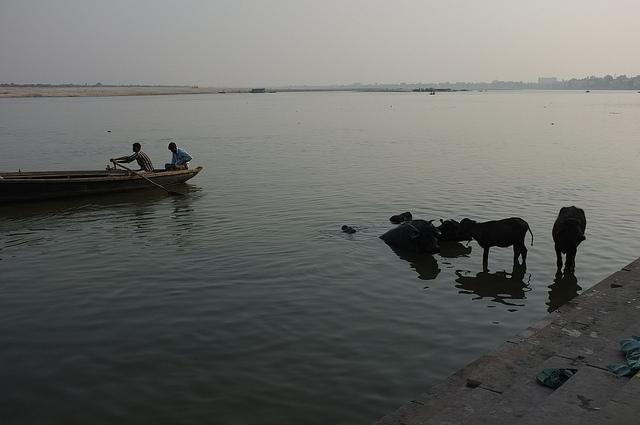Are there animals in the water?
Be succinct. Yes. How many people are on the boat?
Concise answer only. 2. Can this dog swim?
Keep it brief. Yes. Is it a river?
Write a very short answer. Yes. What are the people doing in the water?
Short answer required. Rowing boat. Is the dog on  leash?
Short answer required. No. Which animal is this?
Keep it brief. Cow. 